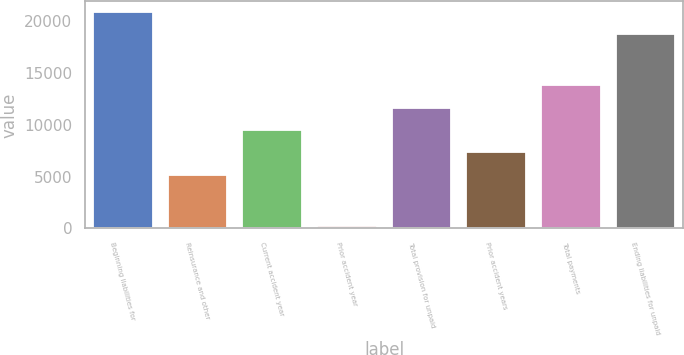Convert chart. <chart><loc_0><loc_0><loc_500><loc_500><bar_chart><fcel>Beginning liabilities for<fcel>Reinsurance and other<fcel>Current accident year<fcel>Prior accident year<fcel>Total provision for unpaid<fcel>Prior accident years<fcel>Total payments<fcel>Ending liabilities for unpaid<nl><fcel>20828.4<fcel>5179.4<fcel>9484.2<fcel>192<fcel>11636.6<fcel>7331.8<fcel>13789<fcel>18676<nl></chart> 